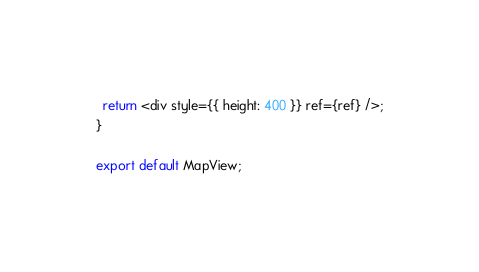<code> <loc_0><loc_0><loc_500><loc_500><_JavaScript_>  return <div style={{ height: 400 }} ref={ref} />;
}

export default MapView;
</code> 